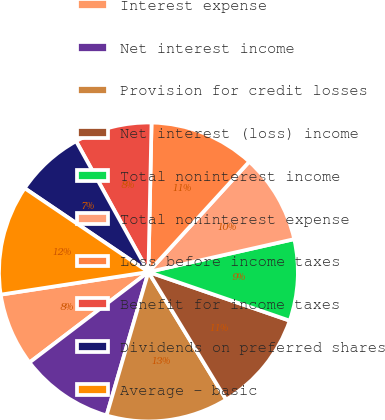<chart> <loc_0><loc_0><loc_500><loc_500><pie_chart><fcel>Interest expense<fcel>Net interest income<fcel>Provision for credit losses<fcel>Net interest (loss) income<fcel>Total noninterest income<fcel>Total noninterest expense<fcel>Loss before income taxes<fcel>Benefit for income taxes<fcel>Dividends on preferred shares<fcel>Average - basic<nl><fcel>7.93%<fcel>10.13%<fcel>13.22%<fcel>11.01%<fcel>8.81%<fcel>9.69%<fcel>11.45%<fcel>8.37%<fcel>7.49%<fcel>11.89%<nl></chart> 